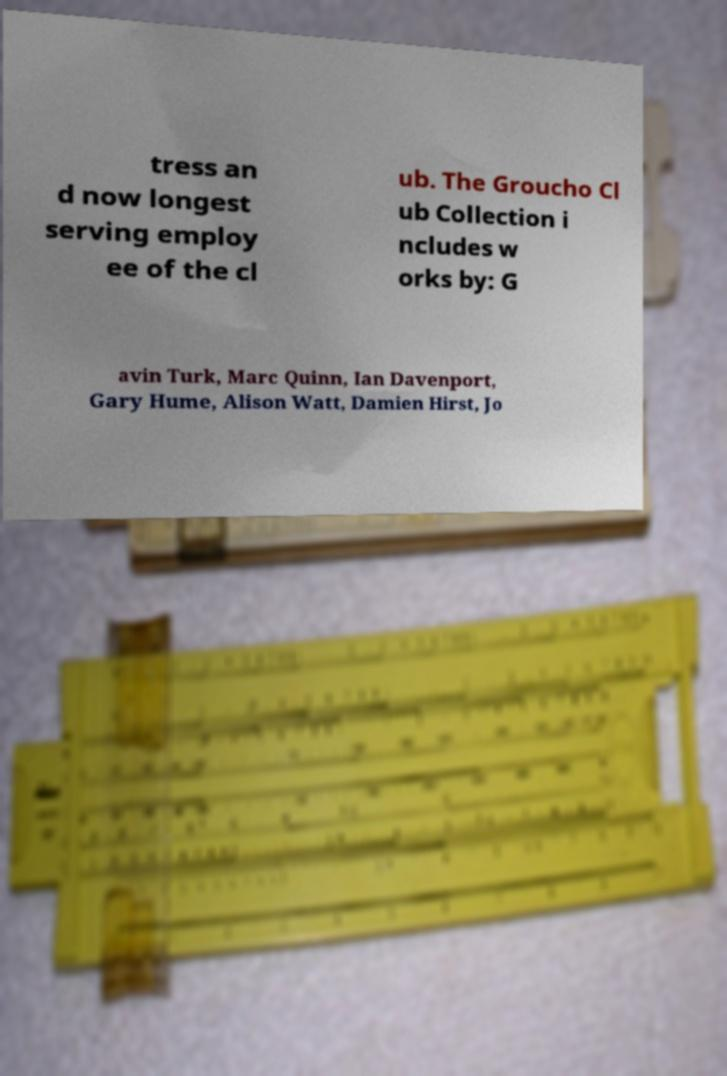Could you assist in decoding the text presented in this image and type it out clearly? tress an d now longest serving employ ee of the cl ub. The Groucho Cl ub Collection i ncludes w orks by: G avin Turk, Marc Quinn, Ian Davenport, Gary Hume, Alison Watt, Damien Hirst, Jo 